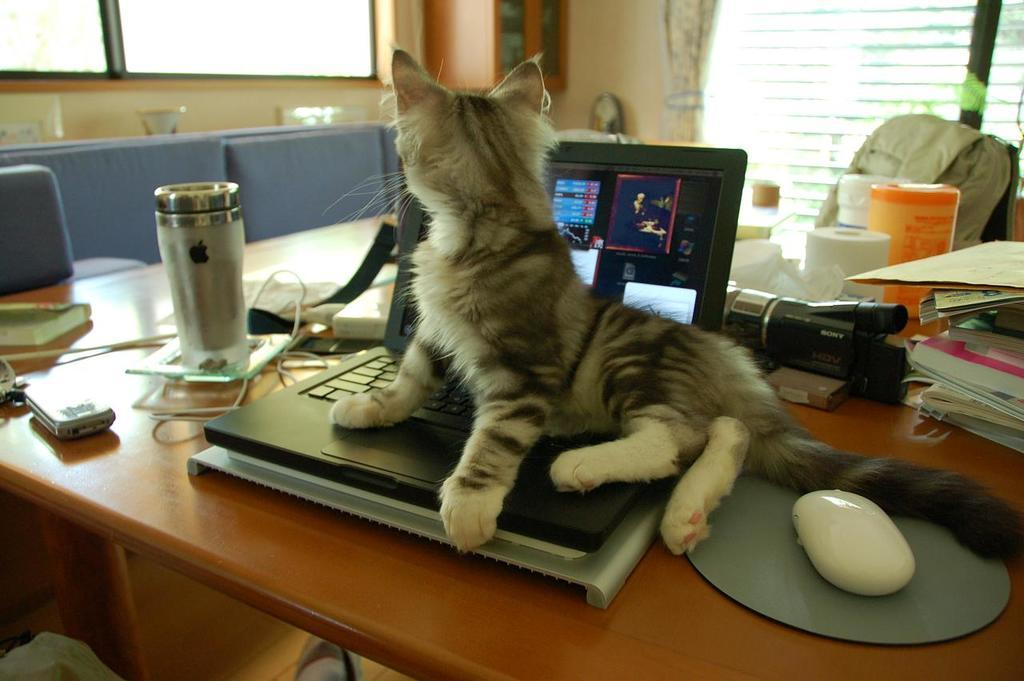What type of animal is in the image? There is a cat in the image. What is the cat sitting on? The cat is sitting on a laptop. Where is the laptop located? The laptop is on a table. Are there any other objects on the table? Yes, there are other objects on the table. What type of jelly can be seen on the farm in the image? There is no jelly or farm present in the image; it features a cat sitting on a laptop on a table. What type of button is the cat pressing on the laptop in the image? There is no button being pressed by the cat in the image; it is simply sitting on the laptop. 